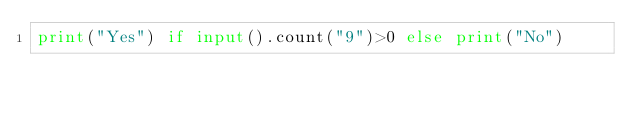<code> <loc_0><loc_0><loc_500><loc_500><_Python_>print("Yes") if input().count("9")>0 else print("No")</code> 